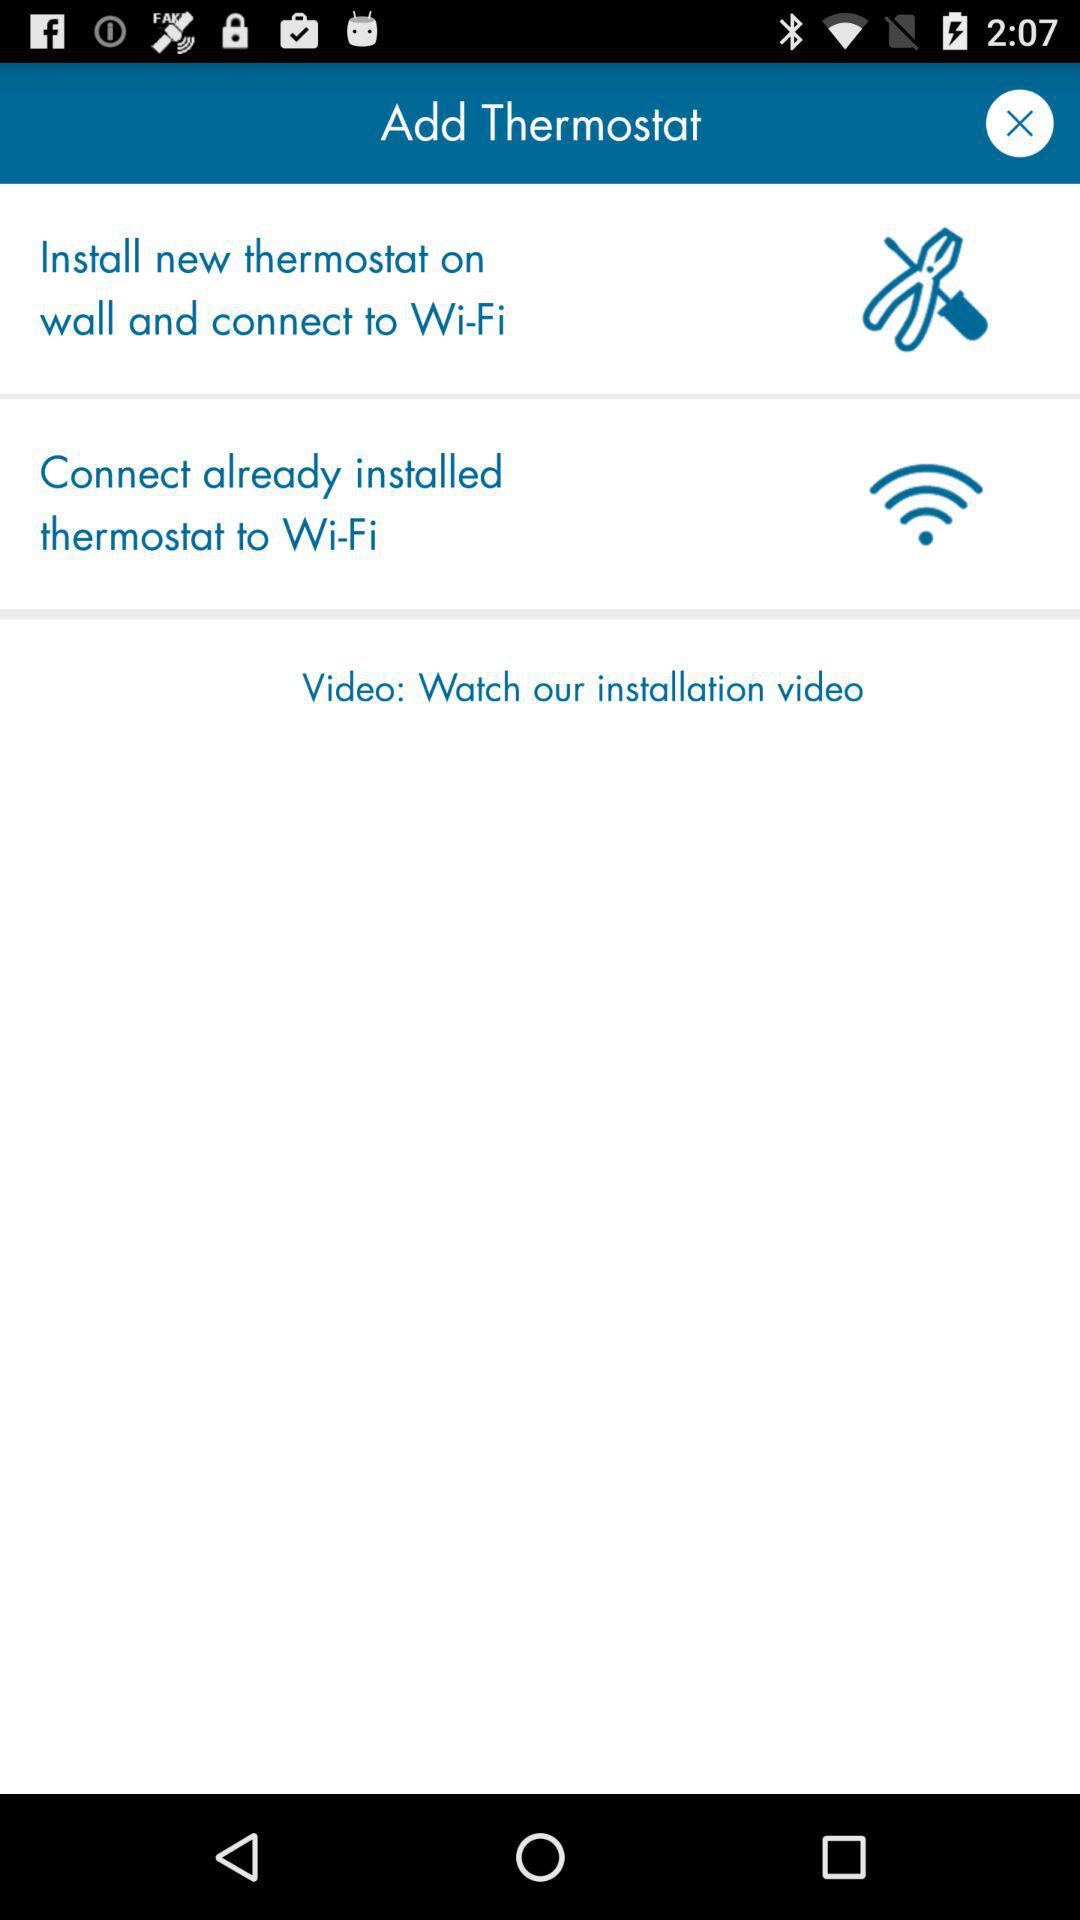How many steps are there to connect a thermostat to Wi-Fi?
Answer the question using a single word or phrase. 2 